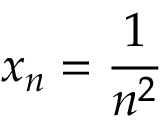<formula> <loc_0><loc_0><loc_500><loc_500>x _ { n } = { \frac { 1 } { n ^ { 2 } } }</formula> 